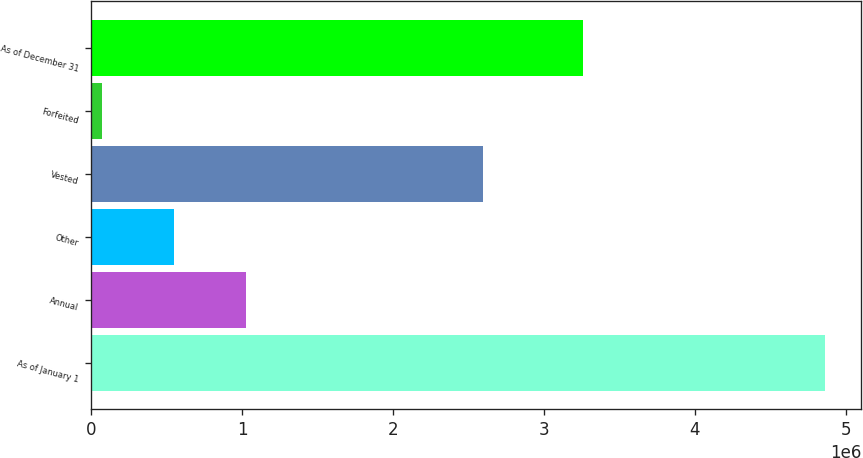Convert chart to OTSL. <chart><loc_0><loc_0><loc_500><loc_500><bar_chart><fcel>As of January 1<fcel>Annual<fcel>Other<fcel>Vested<fcel>Forfeited<fcel>As of December 31<nl><fcel>4.85897e+06<fcel>1.02844e+06<fcel>549618<fcel>2.59447e+06<fcel>70801<fcel>3.26156e+06<nl></chart> 